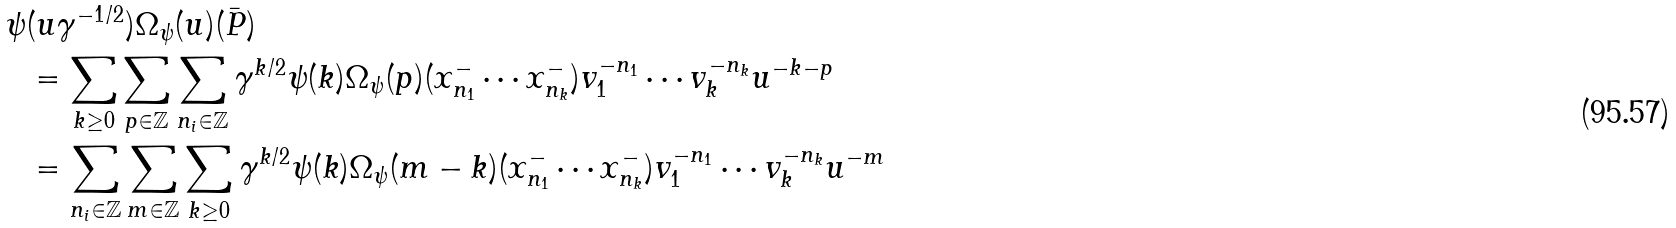<formula> <loc_0><loc_0><loc_500><loc_500>\psi & ( u \gamma ^ { - 1 / 2 } ) \Omega _ { \psi } ( u ) ( \bar { P } ) \\ & = \sum _ { k \geq 0 } \sum _ { p \in \mathbb { Z } } \sum _ { n _ { i } \in \mathbb { Z } } \gamma ^ { k / 2 } \psi ( k ) \Omega _ { \psi } ( p ) ( x ^ { - } _ { n _ { 1 } } \cdots x ^ { - } _ { n _ { k } } ) v _ { 1 } ^ { - n _ { 1 } } \cdots v _ { k } ^ { - n _ { k } } u ^ { - k - p } \\ & = \sum _ { n _ { i } \in \mathbb { Z } } \sum _ { m \in \mathbb { Z } } \sum _ { k \geq 0 } \gamma ^ { k / 2 } \psi ( k ) \Omega _ { \psi } ( m - k ) ( x ^ { - } _ { n _ { 1 } } \cdots x ^ { - } _ { n _ { k } } ) v _ { 1 } ^ { - n _ { 1 } } \cdots v _ { k } ^ { - n _ { k } } u ^ { - m }</formula> 